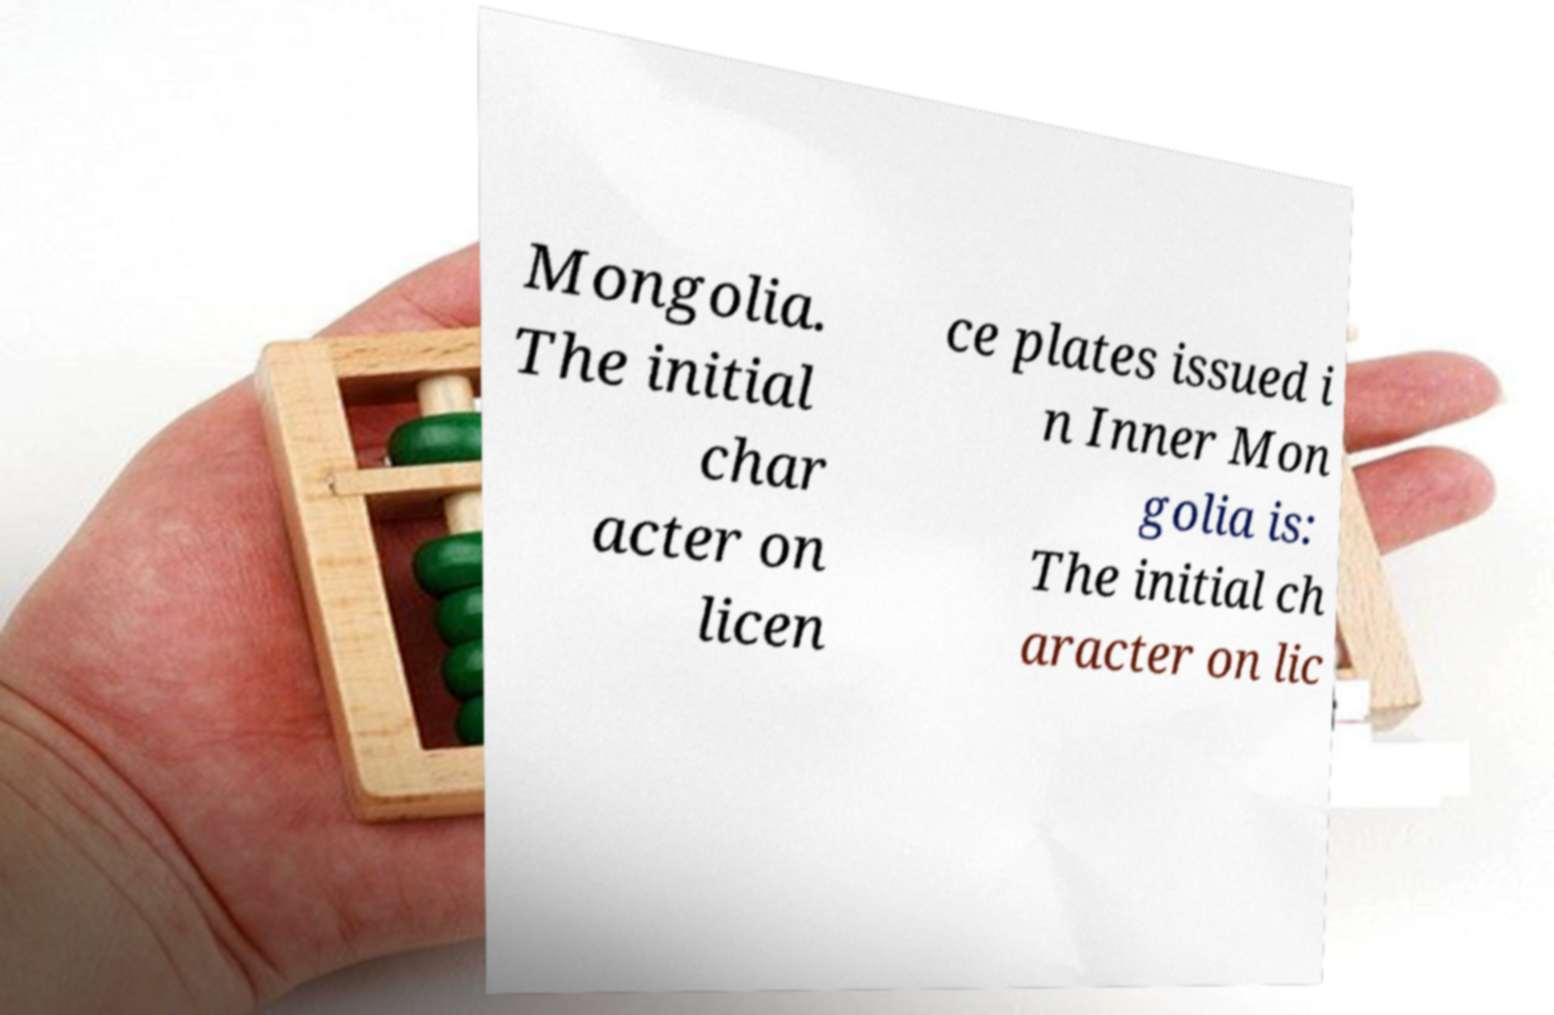Can you accurately transcribe the text from the provided image for me? Mongolia. The initial char acter on licen ce plates issued i n Inner Mon golia is: The initial ch aracter on lic 